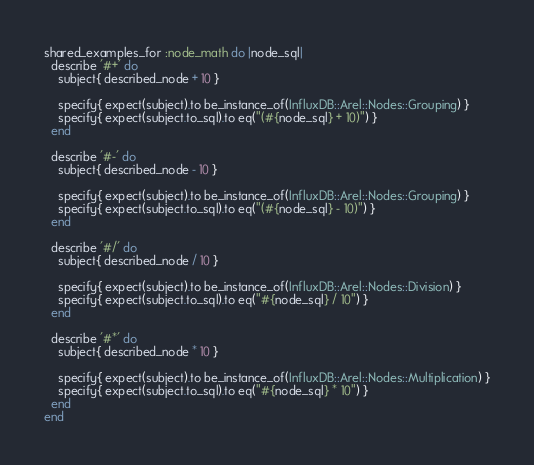<code> <loc_0><loc_0><loc_500><loc_500><_Ruby_>shared_examples_for :node_math do |node_sql|
  describe '#+' do
    subject{ described_node + 10 }

    specify{ expect(subject).to be_instance_of(InfluxDB::Arel::Nodes::Grouping) }
    specify{ expect(subject.to_sql).to eq("(#{node_sql} + 10)") }
  end

  describe '#-' do
    subject{ described_node - 10 }

    specify{ expect(subject).to be_instance_of(InfluxDB::Arel::Nodes::Grouping) }
    specify{ expect(subject.to_sql).to eq("(#{node_sql} - 10)") }
  end

  describe '#/' do
    subject{ described_node / 10 }

    specify{ expect(subject).to be_instance_of(InfluxDB::Arel::Nodes::Division) }
    specify{ expect(subject.to_sql).to eq("#{node_sql} / 10") }
  end

  describe '#*' do
    subject{ described_node * 10 }

    specify{ expect(subject).to be_instance_of(InfluxDB::Arel::Nodes::Multiplication) }
    specify{ expect(subject.to_sql).to eq("#{node_sql} * 10") }
  end
end
</code> 